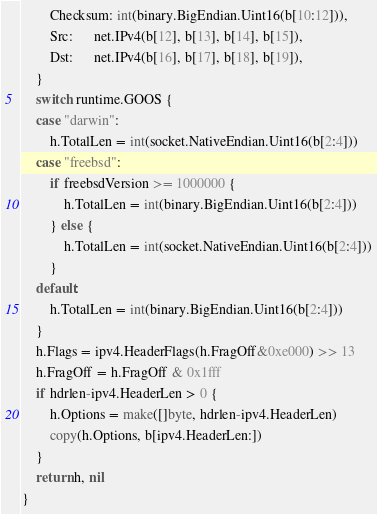<code> <loc_0><loc_0><loc_500><loc_500><_Go_>		Checksum: int(binary.BigEndian.Uint16(b[10:12])),
		Src:      net.IPv4(b[12], b[13], b[14], b[15]),
		Dst:      net.IPv4(b[16], b[17], b[18], b[19]),
	}
	switch runtime.GOOS {
	case "darwin":
		h.TotalLen = int(socket.NativeEndian.Uint16(b[2:4]))
	case "freebsd":
		if freebsdVersion >= 1000000 {
			h.TotalLen = int(binary.BigEndian.Uint16(b[2:4]))
		} else {
			h.TotalLen = int(socket.NativeEndian.Uint16(b[2:4]))
		}
	default:
		h.TotalLen = int(binary.BigEndian.Uint16(b[2:4]))
	}
	h.Flags = ipv4.HeaderFlags(h.FragOff&0xe000) >> 13
	h.FragOff = h.FragOff & 0x1fff
	if hdrlen-ipv4.HeaderLen > 0 {
		h.Options = make([]byte, hdrlen-ipv4.HeaderLen)
		copy(h.Options, b[ipv4.HeaderLen:])
	}
	return h, nil
}
</code> 